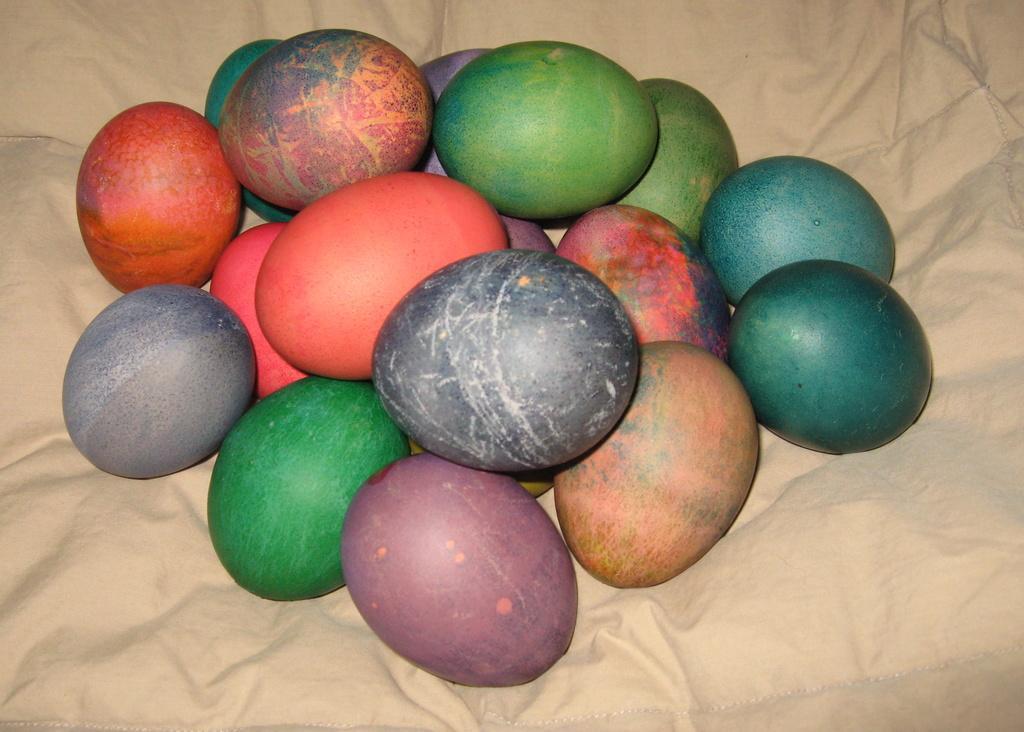Can you describe this image briefly? There are eggs in different colors arranged on a cloth. And the background is cream in color. 